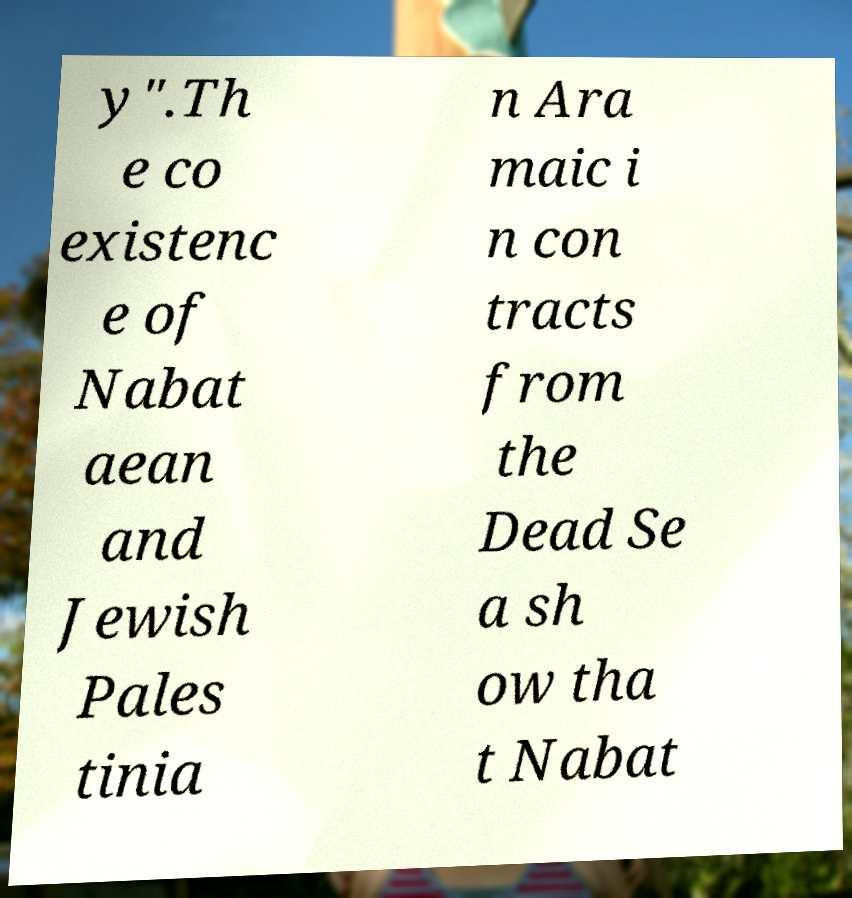Please identify and transcribe the text found in this image. y".Th e co existenc e of Nabat aean and Jewish Pales tinia n Ara maic i n con tracts from the Dead Se a sh ow tha t Nabat 